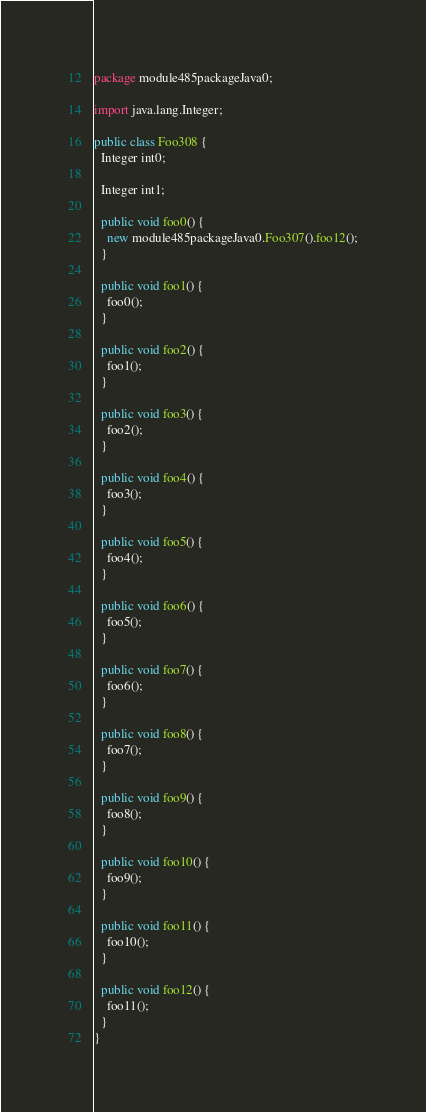Convert code to text. <code><loc_0><loc_0><loc_500><loc_500><_Java_>package module485packageJava0;

import java.lang.Integer;

public class Foo308 {
  Integer int0;

  Integer int1;

  public void foo0() {
    new module485packageJava0.Foo307().foo12();
  }

  public void foo1() {
    foo0();
  }

  public void foo2() {
    foo1();
  }

  public void foo3() {
    foo2();
  }

  public void foo4() {
    foo3();
  }

  public void foo5() {
    foo4();
  }

  public void foo6() {
    foo5();
  }

  public void foo7() {
    foo6();
  }

  public void foo8() {
    foo7();
  }

  public void foo9() {
    foo8();
  }

  public void foo10() {
    foo9();
  }

  public void foo11() {
    foo10();
  }

  public void foo12() {
    foo11();
  }
}
</code> 